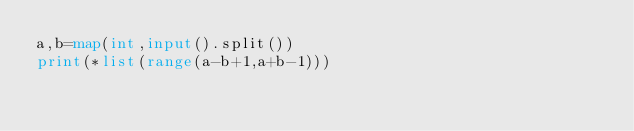Convert code to text. <code><loc_0><loc_0><loc_500><loc_500><_Python_>a,b=map(int,input().split())
print(*list(range(a-b+1,a+b-1)))</code> 